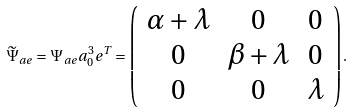<formula> <loc_0><loc_0><loc_500><loc_500>\widetilde { \Psi } _ { a e } = \Psi _ { a e } a _ { 0 } ^ { 3 } e ^ { T } = \left ( \begin{array} { c c c } \alpha + \lambda & 0 & 0 \\ 0 & \beta + \lambda & 0 \\ 0 & 0 & \lambda \\ \end{array} \right ) .</formula> 